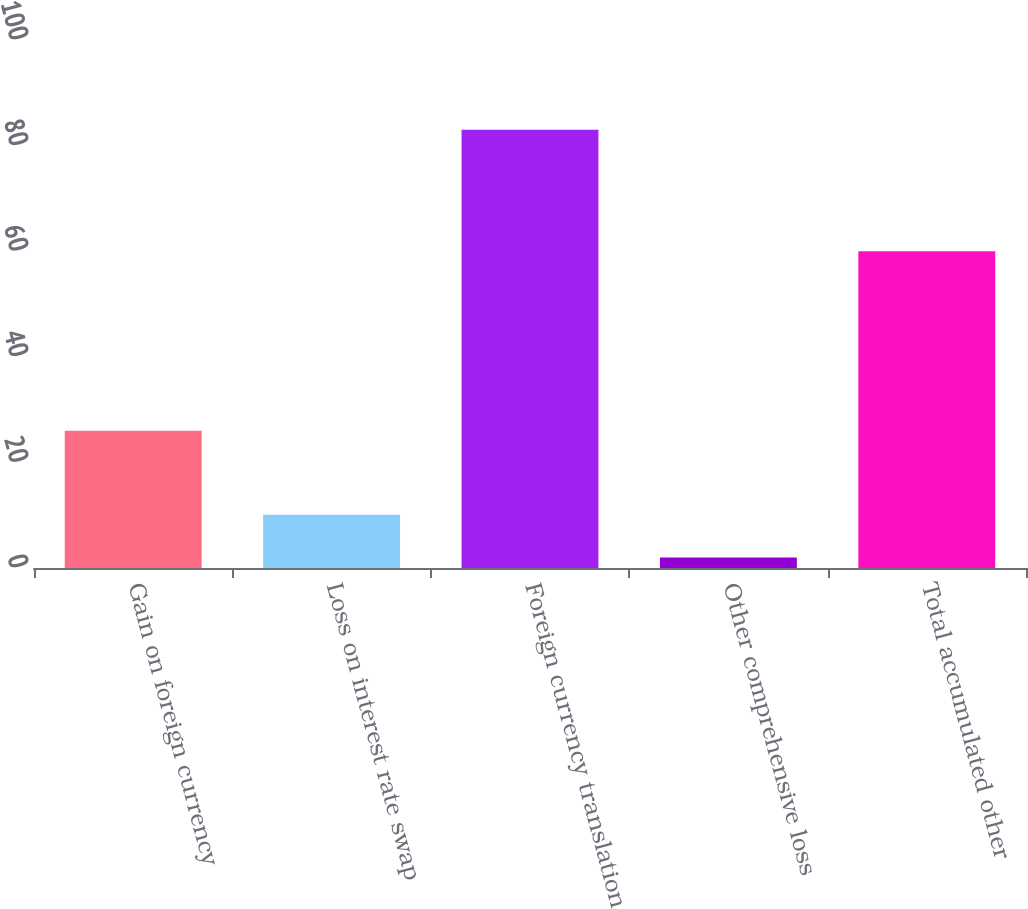Convert chart. <chart><loc_0><loc_0><loc_500><loc_500><bar_chart><fcel>Gain on foreign currency<fcel>Loss on interest rate swap<fcel>Foreign currency translation<fcel>Other comprehensive loss<fcel>Total accumulated other<nl><fcel>26<fcel>10.1<fcel>83<fcel>2<fcel>60<nl></chart> 